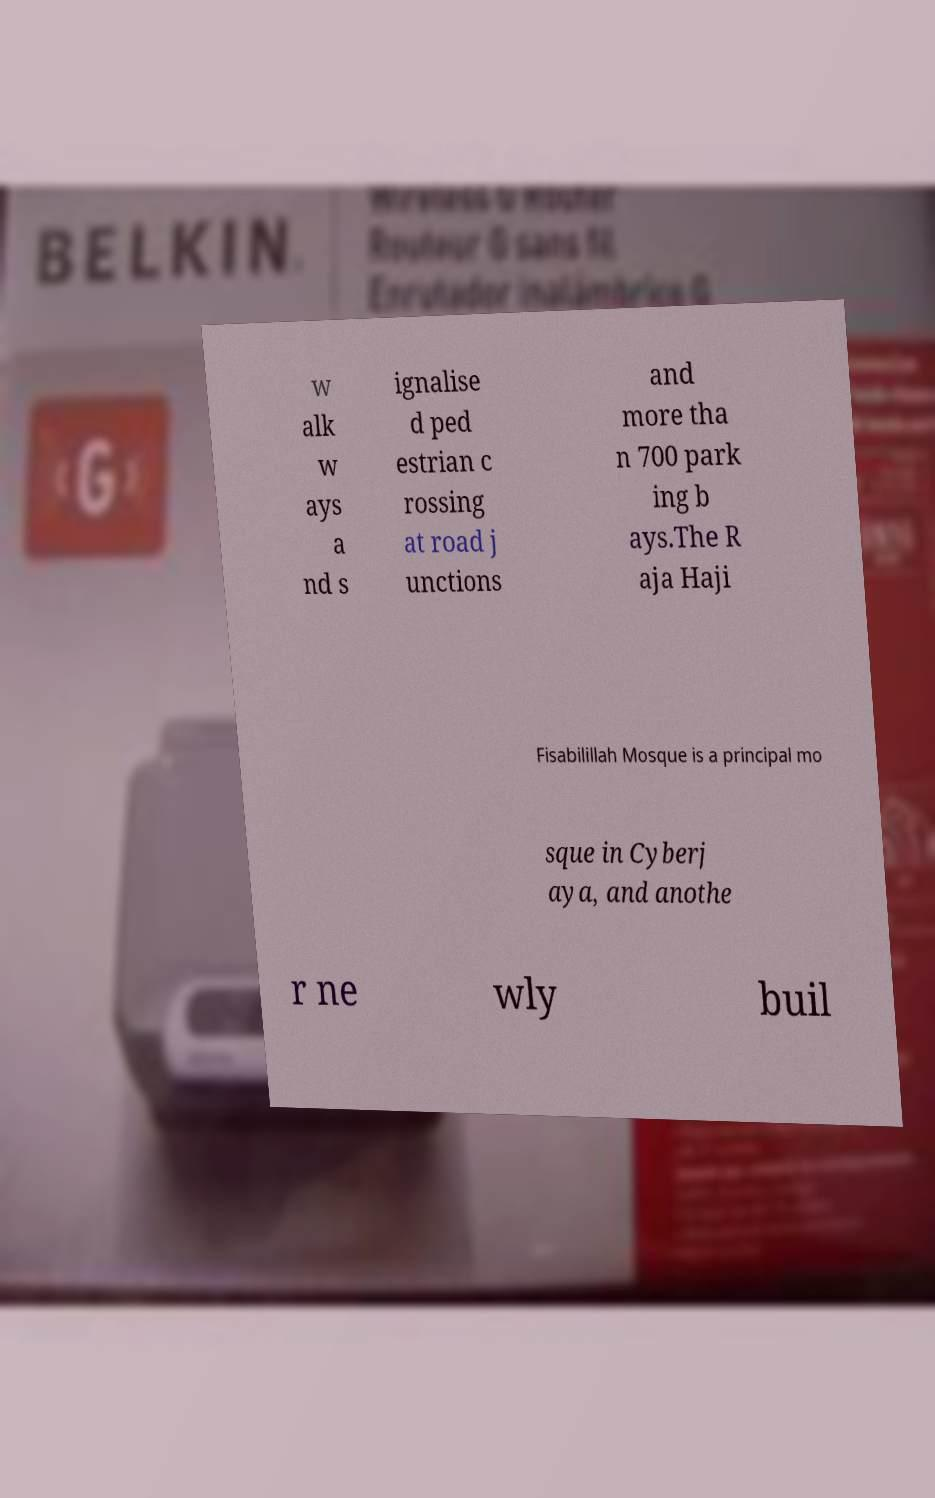Could you assist in decoding the text presented in this image and type it out clearly? w alk w ays a nd s ignalise d ped estrian c rossing at road j unctions and more tha n 700 park ing b ays.The R aja Haji Fisabilillah Mosque is a principal mo sque in Cyberj aya, and anothe r ne wly buil 